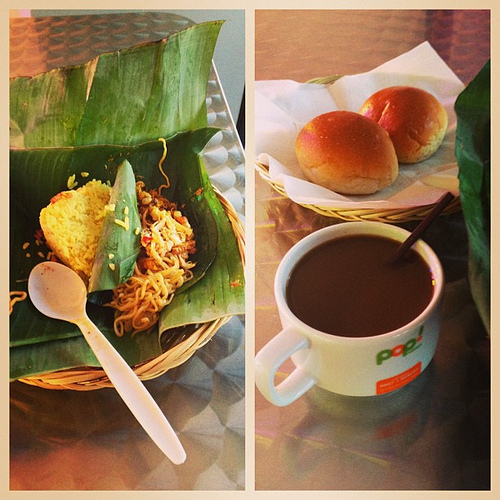What is the spoon made of? By appearance, the spoon seems to be made of a plastic material, suitable for a casual dining setting. 